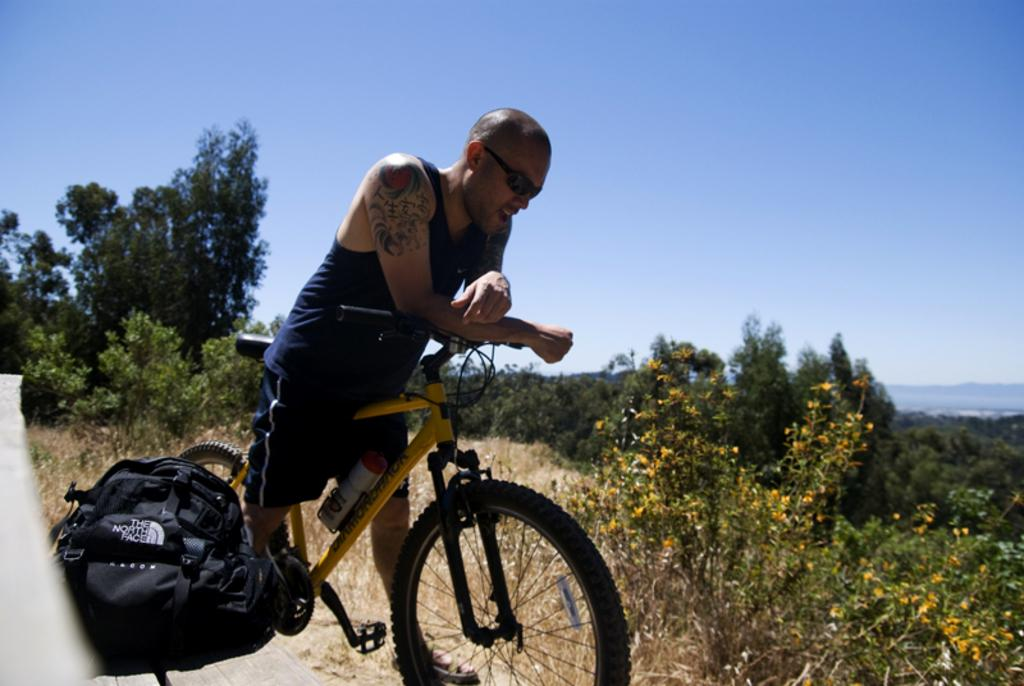What is the main subject of the image? There is a person in the image. What is the person doing in the image? The person is on a bicycle. What can be seen to the right of the person? There is a bag to the right of the person. What is visible in the background of the image? There are trees and the sky visible in the background of the image. What type of cough medicine is the person taking in the image? There is no indication in the image that the person is taking any cough medicine, as the focus is on the person riding a bicycle. 